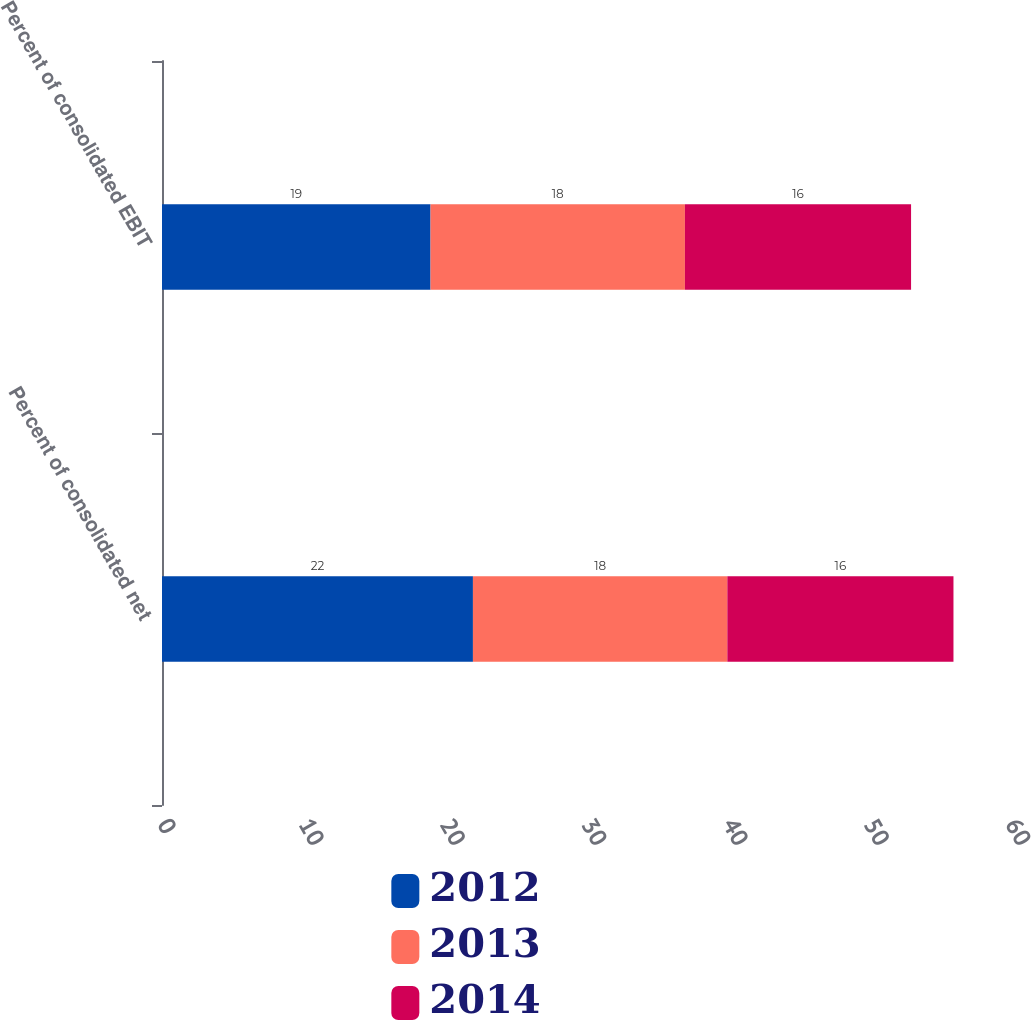Convert chart. <chart><loc_0><loc_0><loc_500><loc_500><stacked_bar_chart><ecel><fcel>Percent of consolidated net<fcel>Percent of consolidated EBIT<nl><fcel>2012<fcel>22<fcel>19<nl><fcel>2013<fcel>18<fcel>18<nl><fcel>2014<fcel>16<fcel>16<nl></chart> 